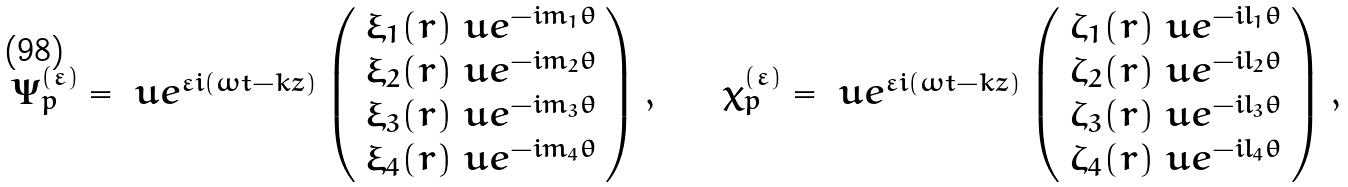<formula> <loc_0><loc_0><loc_500><loc_500>\begin{array} { l l l } \Psi _ { p } ^ { ( \varepsilon ) } = \ u e ^ { \varepsilon i ( \omega t - k z ) } \left ( \begin{array} { l } \xi _ { 1 } ( r ) \ u e ^ { - i m _ { 1 } \theta } \\ \xi _ { 2 } ( r ) \ u e ^ { - i m _ { 2 } \theta } \\ \xi _ { 3 } ( r ) \ u e ^ { - i m _ { 3 } \theta } \\ \xi _ { 4 } ( r ) \ u e ^ { - i m _ { 4 } \theta } \end{array} \right ) , & \quad & { \chi } _ { p } ^ { ( \varepsilon ) } = \ u e ^ { \varepsilon i ( \omega t - k z ) } \left ( \begin{array} { l } \zeta _ { 1 } ( r ) \ u e ^ { - i l _ { 1 } \theta } \\ \zeta _ { 2 } ( r ) \ u e ^ { - i l _ { 2 } \theta } \\ \zeta _ { 3 } ( r ) \ u e ^ { - i l _ { 3 } \theta } \\ \zeta _ { 4 } ( r ) \ u e ^ { - i l _ { 4 } \theta } \end{array} \right ) , \end{array}</formula> 